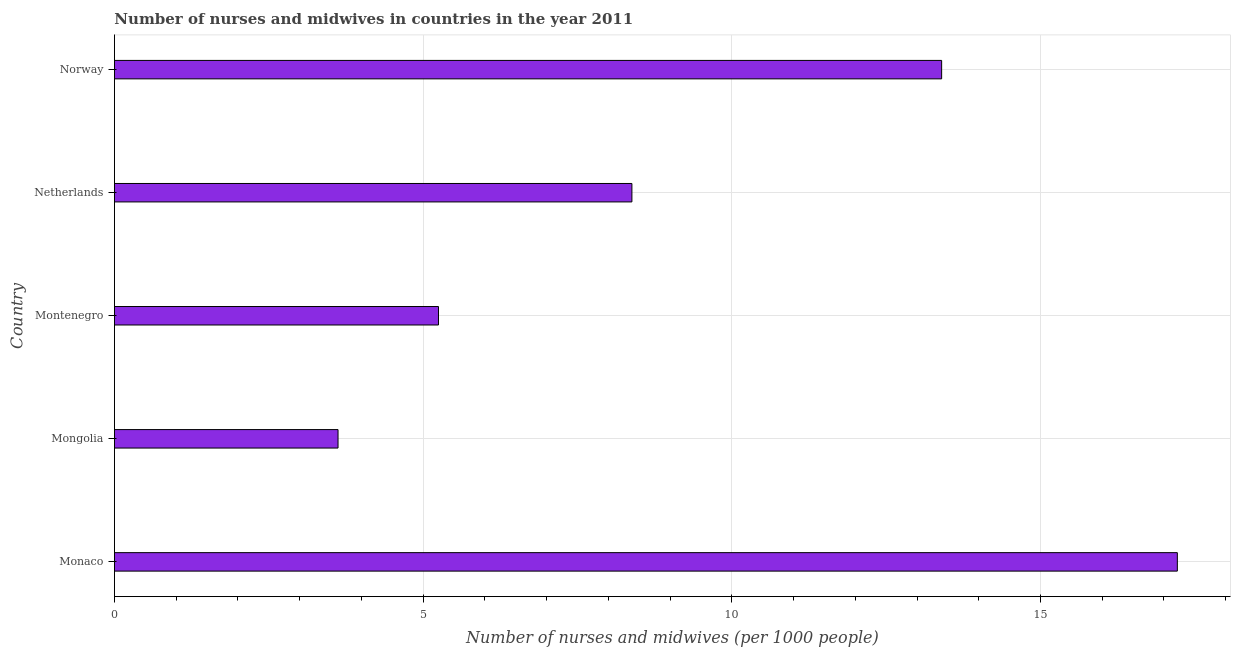Does the graph contain any zero values?
Provide a succinct answer. No. Does the graph contain grids?
Provide a succinct answer. Yes. What is the title of the graph?
Offer a very short reply. Number of nurses and midwives in countries in the year 2011. What is the label or title of the X-axis?
Ensure brevity in your answer.  Number of nurses and midwives (per 1000 people). What is the number of nurses and midwives in Norway?
Provide a short and direct response. 13.4. Across all countries, what is the maximum number of nurses and midwives?
Your response must be concise. 17.22. Across all countries, what is the minimum number of nurses and midwives?
Provide a short and direct response. 3.62. In which country was the number of nurses and midwives maximum?
Your answer should be very brief. Monaco. In which country was the number of nurses and midwives minimum?
Provide a short and direct response. Mongolia. What is the sum of the number of nurses and midwives?
Your answer should be very brief. 47.87. What is the difference between the number of nurses and midwives in Mongolia and Montenegro?
Ensure brevity in your answer.  -1.63. What is the average number of nurses and midwives per country?
Keep it short and to the point. 9.57. What is the median number of nurses and midwives?
Keep it short and to the point. 8.38. What is the ratio of the number of nurses and midwives in Montenegro to that in Norway?
Keep it short and to the point. 0.39. Is the difference between the number of nurses and midwives in Montenegro and Norway greater than the difference between any two countries?
Make the answer very short. No. What is the difference between the highest and the second highest number of nurses and midwives?
Ensure brevity in your answer.  3.82. What is the difference between the highest and the lowest number of nurses and midwives?
Your answer should be very brief. 13.59. In how many countries, is the number of nurses and midwives greater than the average number of nurses and midwives taken over all countries?
Provide a short and direct response. 2. How many bars are there?
Make the answer very short. 5. Are all the bars in the graph horizontal?
Make the answer very short. Yes. What is the difference between two consecutive major ticks on the X-axis?
Provide a succinct answer. 5. What is the Number of nurses and midwives (per 1000 people) of Monaco?
Make the answer very short. 17.22. What is the Number of nurses and midwives (per 1000 people) of Mongolia?
Your answer should be compact. 3.62. What is the Number of nurses and midwives (per 1000 people) in Montenegro?
Provide a succinct answer. 5.25. What is the Number of nurses and midwives (per 1000 people) in Netherlands?
Keep it short and to the point. 8.38. What is the Number of nurses and midwives (per 1000 people) in Norway?
Your response must be concise. 13.4. What is the difference between the Number of nurses and midwives (per 1000 people) in Monaco and Mongolia?
Your response must be concise. 13.6. What is the difference between the Number of nurses and midwives (per 1000 people) in Monaco and Montenegro?
Your answer should be compact. 11.97. What is the difference between the Number of nurses and midwives (per 1000 people) in Monaco and Netherlands?
Your response must be concise. 8.84. What is the difference between the Number of nurses and midwives (per 1000 people) in Monaco and Norway?
Make the answer very short. 3.82. What is the difference between the Number of nurses and midwives (per 1000 people) in Mongolia and Montenegro?
Your response must be concise. -1.63. What is the difference between the Number of nurses and midwives (per 1000 people) in Mongolia and Netherlands?
Make the answer very short. -4.76. What is the difference between the Number of nurses and midwives (per 1000 people) in Mongolia and Norway?
Your answer should be very brief. -9.78. What is the difference between the Number of nurses and midwives (per 1000 people) in Montenegro and Netherlands?
Your response must be concise. -3.13. What is the difference between the Number of nurses and midwives (per 1000 people) in Montenegro and Norway?
Provide a succinct answer. -8.15. What is the difference between the Number of nurses and midwives (per 1000 people) in Netherlands and Norway?
Offer a terse response. -5.02. What is the ratio of the Number of nurses and midwives (per 1000 people) in Monaco to that in Mongolia?
Provide a succinct answer. 4.75. What is the ratio of the Number of nurses and midwives (per 1000 people) in Monaco to that in Montenegro?
Give a very brief answer. 3.28. What is the ratio of the Number of nurses and midwives (per 1000 people) in Monaco to that in Netherlands?
Provide a short and direct response. 2.05. What is the ratio of the Number of nurses and midwives (per 1000 people) in Monaco to that in Norway?
Give a very brief answer. 1.28. What is the ratio of the Number of nurses and midwives (per 1000 people) in Mongolia to that in Montenegro?
Ensure brevity in your answer.  0.69. What is the ratio of the Number of nurses and midwives (per 1000 people) in Mongolia to that in Netherlands?
Offer a very short reply. 0.43. What is the ratio of the Number of nurses and midwives (per 1000 people) in Mongolia to that in Norway?
Your answer should be compact. 0.27. What is the ratio of the Number of nurses and midwives (per 1000 people) in Montenegro to that in Netherlands?
Keep it short and to the point. 0.63. What is the ratio of the Number of nurses and midwives (per 1000 people) in Montenegro to that in Norway?
Keep it short and to the point. 0.39. What is the ratio of the Number of nurses and midwives (per 1000 people) in Netherlands to that in Norway?
Your answer should be compact. 0.63. 